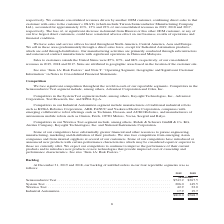According to Teradyne's financial document, What can delays in delivery schedules or cancellations of backlog result in? Based on the financial document, the answer is could have a material adverse effect on our business, financial condition or results of operations. Also, What are the reportable segments in the table? The document contains multiple relevant values: Semiconductor Test, System Test, Wireless Test, Industrial Automation. From the document: "stem Test . 206.0 149.5 Wireless Test . 42.9 32.0 Industrial Automation . 17.9 19.7 or Test . $543.2 $367.5 System Test . 206.0 149.5 Wireless Test . ..." Also, In which years was the backlog of unfilled orders provided? The document shows two values: 2019 and 2018. From the document: "2019 2018 2019 2018..." Additionally, In which year was Industrial Automation larger? According to the financial document, 2018. The relevant text states: "2019 2018..." Also, can you calculate: What was the change in Wireless Test in 2019 from 2018? Based on the calculation: 42.9-32.0, the result is 10.9 (in millions). This is based on the information: "$367.5 System Test . 206.0 149.5 Wireless Test . 42.9 32.0 Industrial Automation . 17.9 19.7 .5 System Test . 206.0 149.5 Wireless Test . 42.9 32.0 Industrial Automation . 17.9 19.7..." The key data points involved are: 32.0, 42.9. Also, can you calculate: What was the percentage change in Wireless Test in 2019 from 2018? To answer this question, I need to perform calculations using the financial data. The calculation is: (42.9-32.0)/32.0, which equals 34.06 (percentage). This is based on the information: "$367.5 System Test . 206.0 149.5 Wireless Test . 42.9 32.0 Industrial Automation . 17.9 19.7 .5 System Test . 206.0 149.5 Wireless Test . 42.9 32.0 Industrial Automation . 17.9 19.7..." The key data points involved are: 32.0, 42.9. 